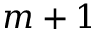Convert formula to latex. <formula><loc_0><loc_0><loc_500><loc_500>m + 1</formula> 